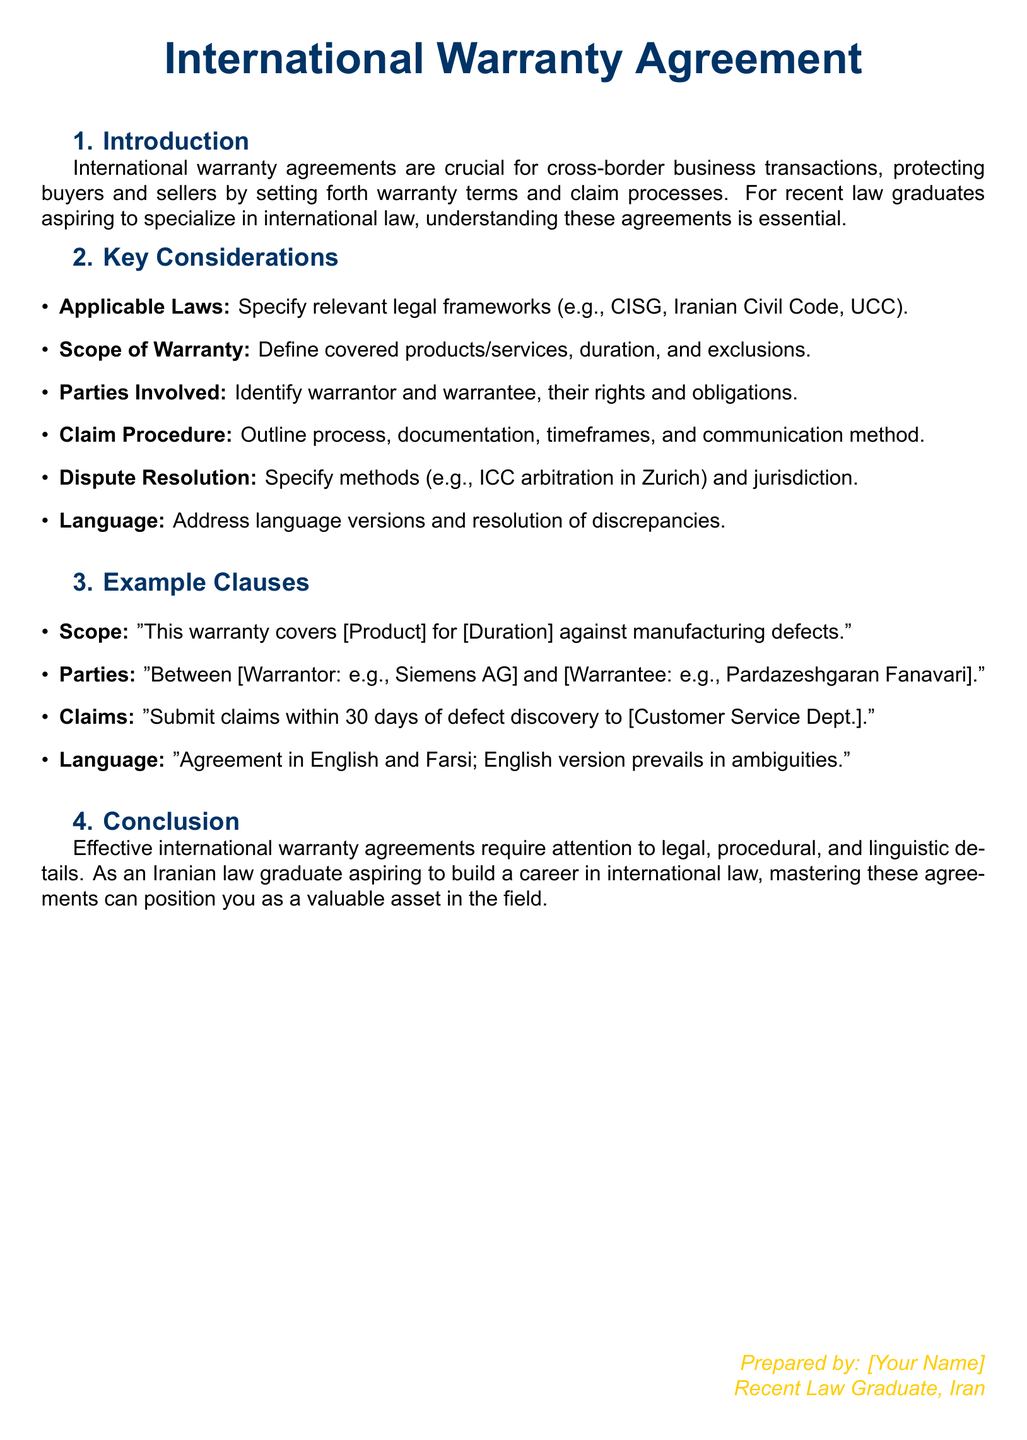What is the title of the document? The title is the heading at the beginning of the document, which conveys the main subject matter.
Answer: International Warranty Agreement Who is the author of the document? The document includes a section where the author identifies themselves, indicating their professional status.
Answer: [Your Name] What does CISG stand for? The document refers to "CISG" as one of the applicable legal frameworks but does not spell it out.
Answer: United Nations Convention on Contracts for the International Sale of Goods What is the time frame for submitting claims? The document specifies a duration for claim submission in the claims clause.
Answer: 30 days What is the main purpose of international warranty agreements? The introduction provides a brief overview of the purpose and significance of these agreements.
Answer: Protecting buyers and sellers What method of dispute resolution is mentioned? The document outlines a specific method for resolving disputes in the relevant section.
Answer: ICC arbitration in Zurich Which two languages are mentioned in the document? The document states the languages relevant for the agreement and their precedence in case of discrepancies.
Answer: English and Farsi What are the two parties involved in the example clause? The document provides an example clause that lists the parties involved in the warranty agreement.
Answer: Siemens AG and Pardazeshgaran Fanavari What is the focus area of the document? The conclusion section of the document highlights an important aspect for aspiring legal practitioners.
Answer: Effective international warranty agreements 